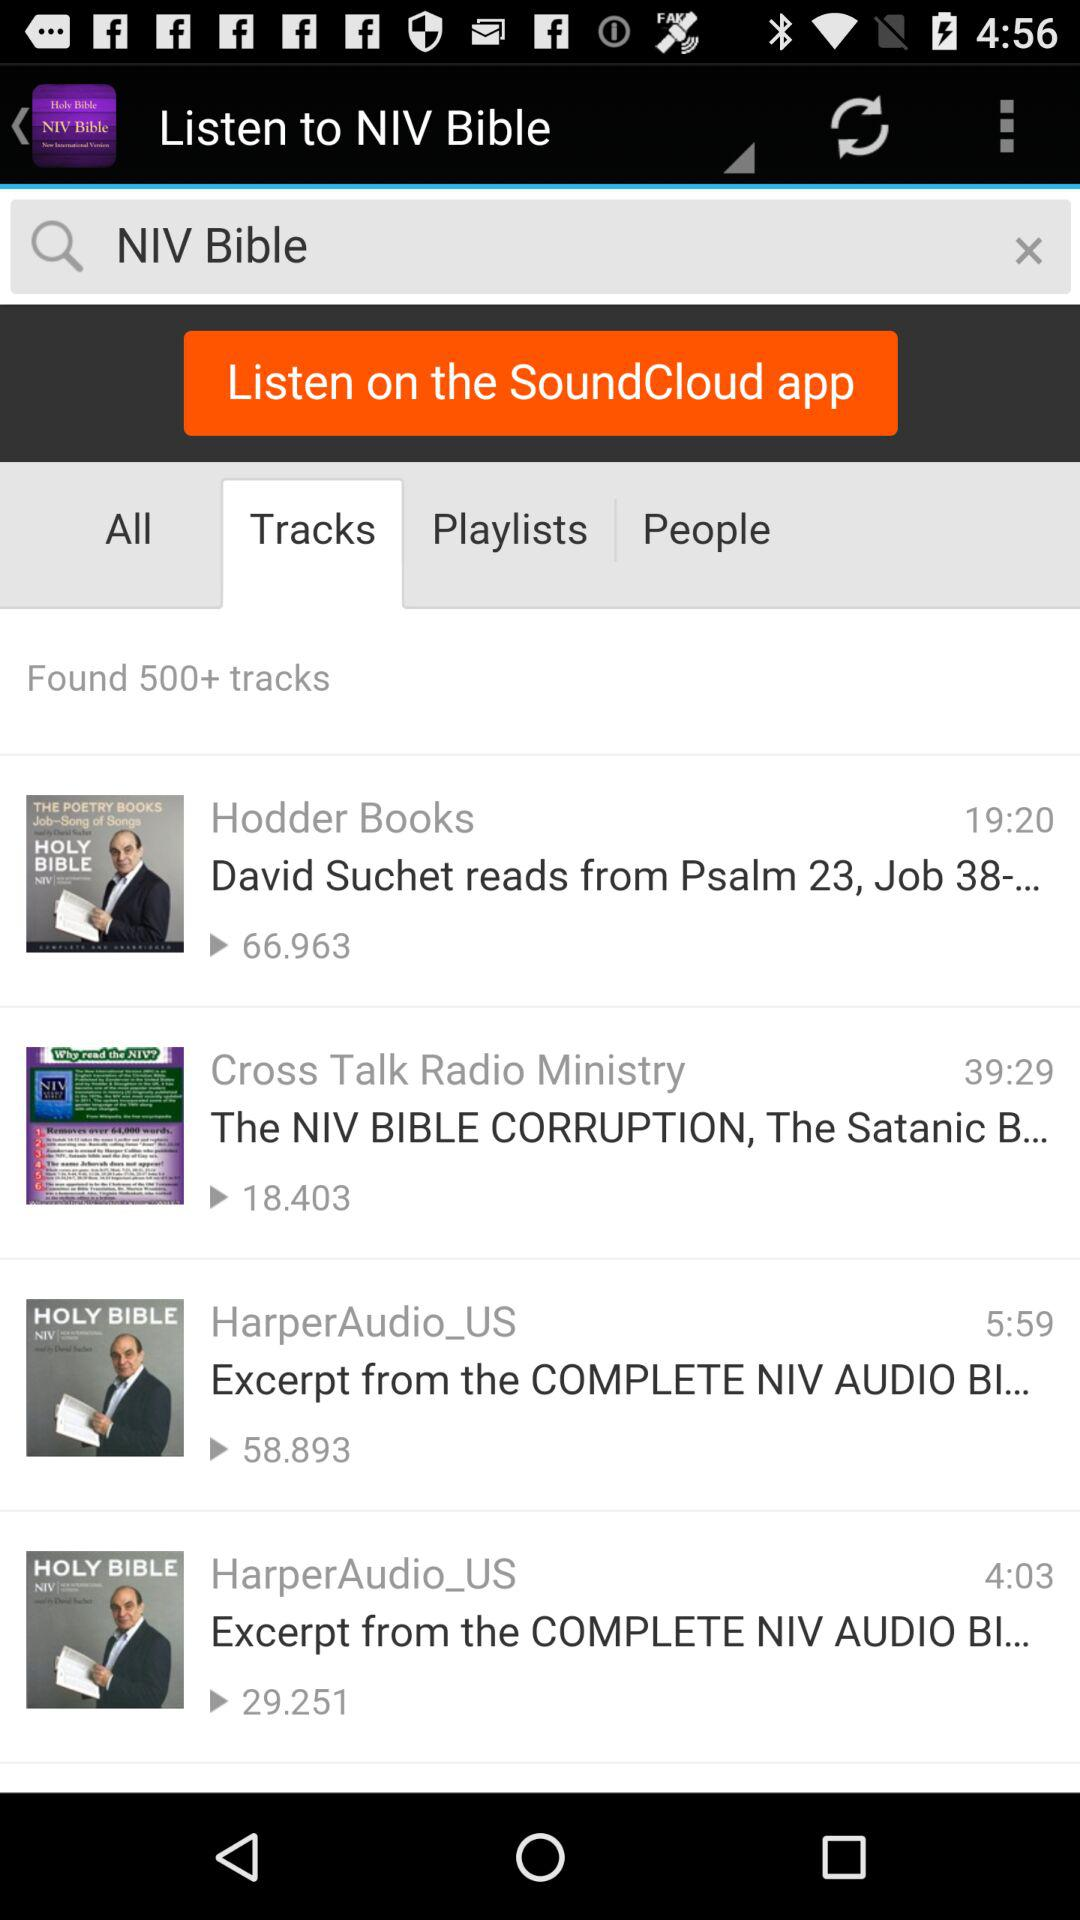Which tab is selected? The selected tab is "Tracks". 